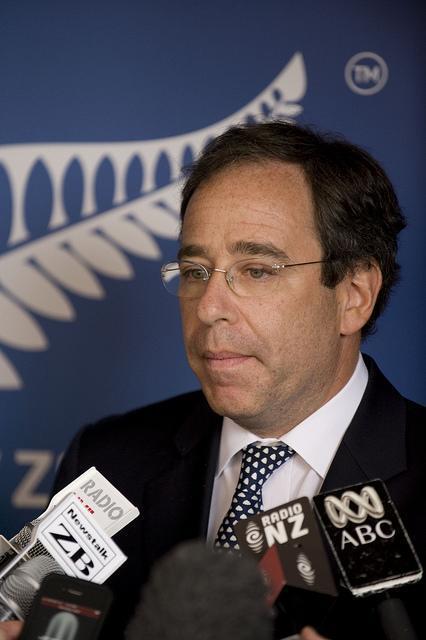How many ties are there?
Give a very brief answer. 1. 